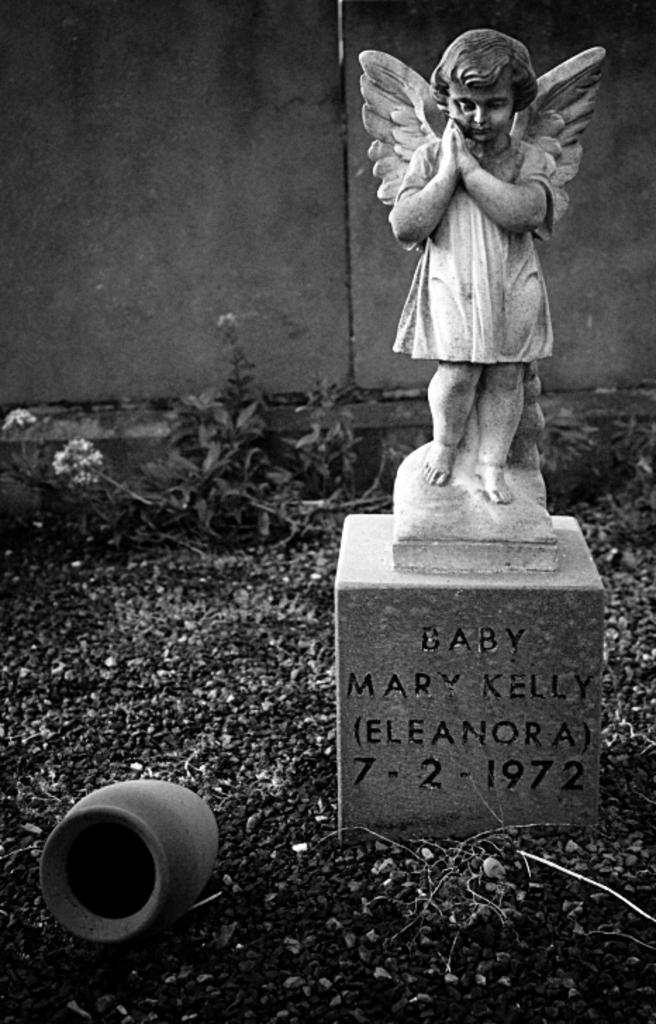What is the main subject on the platform in the image? There is a sculpture on a platform in the image. What else can be seen on the ground in the image? There is a pot on the ground in the image. What type of vegetation is visible in the background of the image? There are plants in the background of the image. What architectural feature is present in the background of the image? There is a wall in the background of the image. What type of nerve can be seen in the image? There is no nerve present in the image; it features a sculpture on a platform, a pot on the ground, plants in the background, and a wall in the background. 